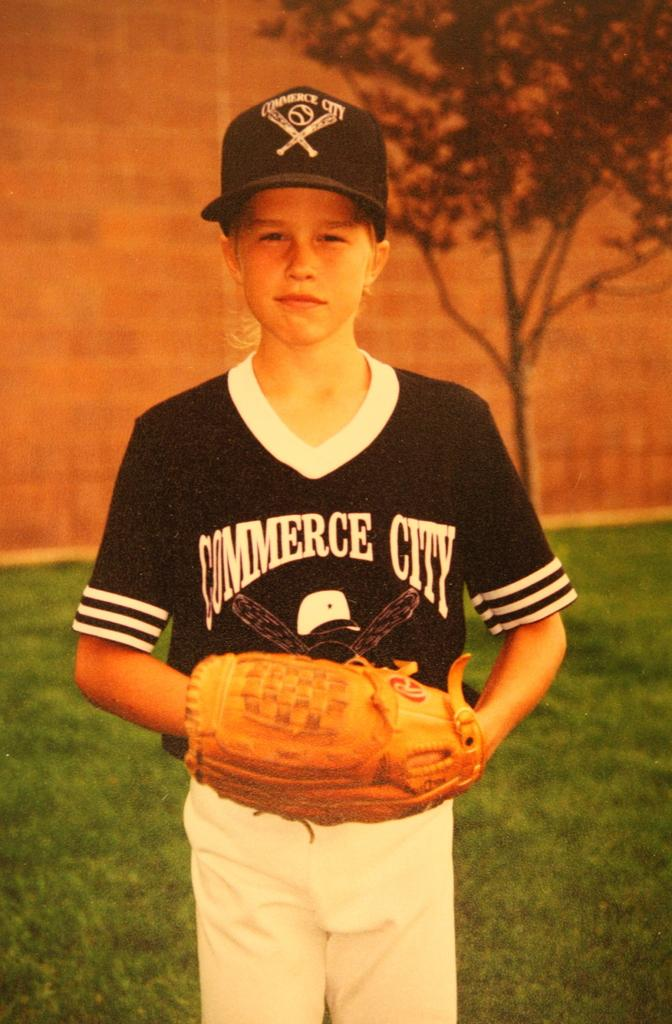<image>
Relay a brief, clear account of the picture shown. a little boy that's wearing a jersey that says 'commerce city' on it 